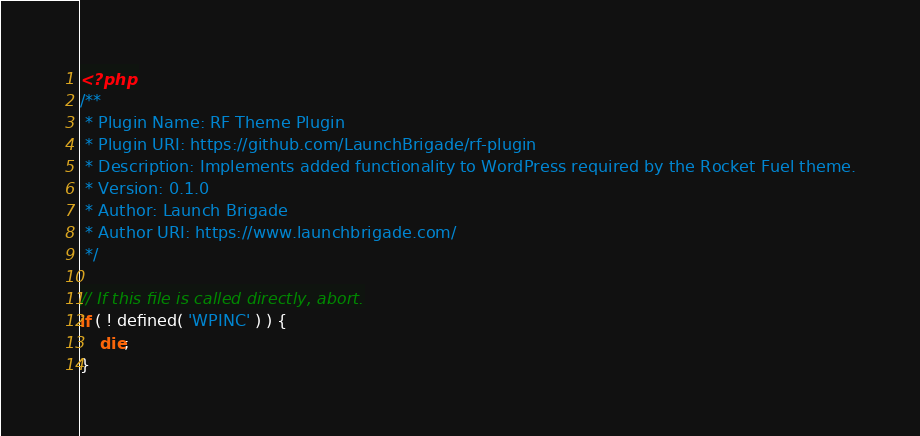<code> <loc_0><loc_0><loc_500><loc_500><_PHP_><?php
/**
 * Plugin Name: RF Theme Plugin
 * Plugin URI: https://github.com/LaunchBrigade/rf-plugin
 * Description: Implements added functionality to WordPress required by the Rocket Fuel theme.
 * Version: 0.1.0
 * Author: Launch Brigade
 * Author URI: https://www.launchbrigade.com/
 */

// If this file is called directly, abort.
if ( ! defined( 'WPINC' ) ) {
	die;
}

</code> 